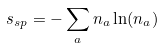<formula> <loc_0><loc_0><loc_500><loc_500>s _ { s p } = - \sum _ { a } { n _ { a } \ln ( n _ { a } ) }</formula> 